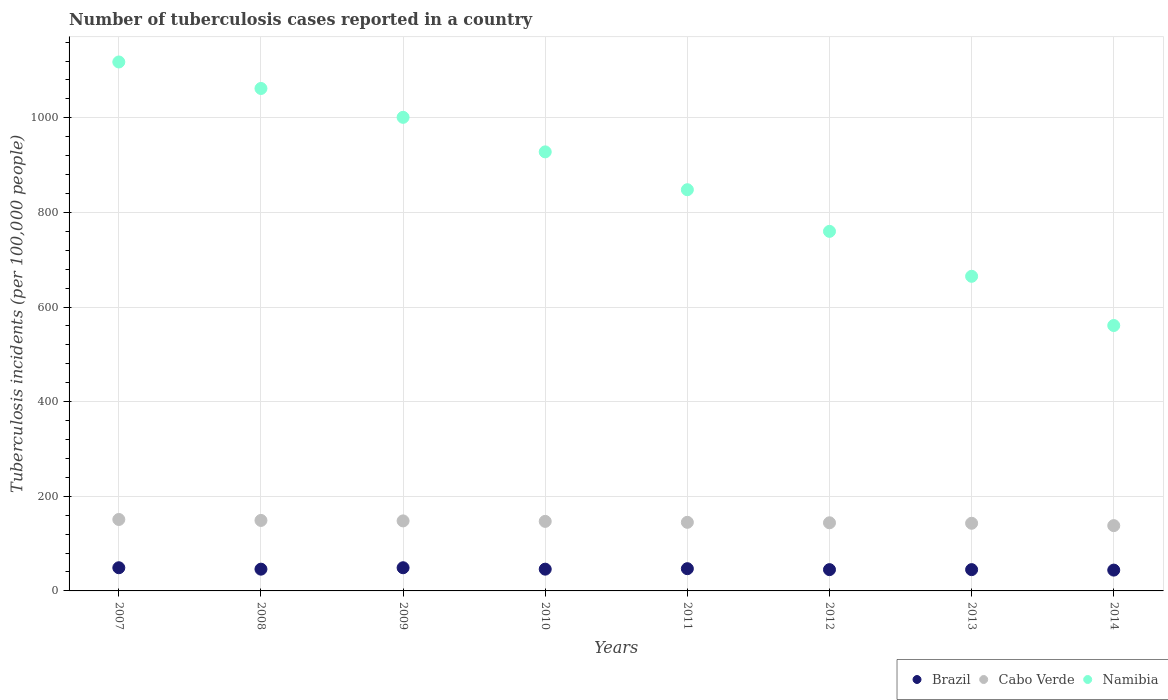Is the number of dotlines equal to the number of legend labels?
Offer a very short reply. Yes. What is the number of tuberculosis cases reported in in Namibia in 2010?
Ensure brevity in your answer.  928. Across all years, what is the maximum number of tuberculosis cases reported in in Cabo Verde?
Offer a very short reply. 151. Across all years, what is the minimum number of tuberculosis cases reported in in Cabo Verde?
Provide a short and direct response. 138. In which year was the number of tuberculosis cases reported in in Cabo Verde maximum?
Provide a short and direct response. 2007. What is the total number of tuberculosis cases reported in in Namibia in the graph?
Make the answer very short. 6943. What is the difference between the number of tuberculosis cases reported in in Cabo Verde in 2009 and that in 2012?
Provide a succinct answer. 4. What is the difference between the number of tuberculosis cases reported in in Namibia in 2014 and the number of tuberculosis cases reported in in Cabo Verde in 2007?
Provide a short and direct response. 410. What is the average number of tuberculosis cases reported in in Namibia per year?
Provide a short and direct response. 867.88. In the year 2008, what is the difference between the number of tuberculosis cases reported in in Cabo Verde and number of tuberculosis cases reported in in Brazil?
Your response must be concise. 103. In how many years, is the number of tuberculosis cases reported in in Namibia greater than 40?
Offer a terse response. 8. What is the ratio of the number of tuberculosis cases reported in in Cabo Verde in 2009 to that in 2014?
Provide a short and direct response. 1.07. Is the difference between the number of tuberculosis cases reported in in Cabo Verde in 2007 and 2012 greater than the difference between the number of tuberculosis cases reported in in Brazil in 2007 and 2012?
Your answer should be very brief. Yes. What is the difference between the highest and the lowest number of tuberculosis cases reported in in Namibia?
Keep it short and to the point. 557. Does the number of tuberculosis cases reported in in Namibia monotonically increase over the years?
Offer a terse response. No. Is the number of tuberculosis cases reported in in Namibia strictly greater than the number of tuberculosis cases reported in in Brazil over the years?
Provide a short and direct response. Yes. How many years are there in the graph?
Provide a short and direct response. 8. What is the difference between two consecutive major ticks on the Y-axis?
Your answer should be compact. 200. Are the values on the major ticks of Y-axis written in scientific E-notation?
Make the answer very short. No. Does the graph contain any zero values?
Keep it short and to the point. No. Does the graph contain grids?
Give a very brief answer. Yes. How are the legend labels stacked?
Make the answer very short. Horizontal. What is the title of the graph?
Your answer should be very brief. Number of tuberculosis cases reported in a country. Does "Low income" appear as one of the legend labels in the graph?
Ensure brevity in your answer.  No. What is the label or title of the X-axis?
Offer a terse response. Years. What is the label or title of the Y-axis?
Make the answer very short. Tuberculosis incidents (per 100,0 people). What is the Tuberculosis incidents (per 100,000 people) of Cabo Verde in 2007?
Your answer should be very brief. 151. What is the Tuberculosis incidents (per 100,000 people) in Namibia in 2007?
Offer a terse response. 1118. What is the Tuberculosis incidents (per 100,000 people) in Cabo Verde in 2008?
Ensure brevity in your answer.  149. What is the Tuberculosis incidents (per 100,000 people) of Namibia in 2008?
Provide a succinct answer. 1062. What is the Tuberculosis incidents (per 100,000 people) of Brazil in 2009?
Make the answer very short. 49. What is the Tuberculosis incidents (per 100,000 people) in Cabo Verde in 2009?
Your response must be concise. 148. What is the Tuberculosis incidents (per 100,000 people) in Namibia in 2009?
Offer a terse response. 1001. What is the Tuberculosis incidents (per 100,000 people) in Cabo Verde in 2010?
Provide a succinct answer. 147. What is the Tuberculosis incidents (per 100,000 people) of Namibia in 2010?
Your answer should be very brief. 928. What is the Tuberculosis incidents (per 100,000 people) in Brazil in 2011?
Your answer should be compact. 47. What is the Tuberculosis incidents (per 100,000 people) in Cabo Verde in 2011?
Provide a short and direct response. 145. What is the Tuberculosis incidents (per 100,000 people) of Namibia in 2011?
Ensure brevity in your answer.  848. What is the Tuberculosis incidents (per 100,000 people) in Cabo Verde in 2012?
Offer a terse response. 144. What is the Tuberculosis incidents (per 100,000 people) in Namibia in 2012?
Your response must be concise. 760. What is the Tuberculosis incidents (per 100,000 people) in Brazil in 2013?
Your response must be concise. 45. What is the Tuberculosis incidents (per 100,000 people) in Cabo Verde in 2013?
Your answer should be very brief. 143. What is the Tuberculosis incidents (per 100,000 people) in Namibia in 2013?
Your answer should be compact. 665. What is the Tuberculosis incidents (per 100,000 people) of Brazil in 2014?
Offer a terse response. 44. What is the Tuberculosis incidents (per 100,000 people) in Cabo Verde in 2014?
Provide a succinct answer. 138. What is the Tuberculosis incidents (per 100,000 people) in Namibia in 2014?
Your response must be concise. 561. Across all years, what is the maximum Tuberculosis incidents (per 100,000 people) in Cabo Verde?
Provide a succinct answer. 151. Across all years, what is the maximum Tuberculosis incidents (per 100,000 people) of Namibia?
Provide a succinct answer. 1118. Across all years, what is the minimum Tuberculosis incidents (per 100,000 people) of Brazil?
Give a very brief answer. 44. Across all years, what is the minimum Tuberculosis incidents (per 100,000 people) in Cabo Verde?
Your answer should be very brief. 138. Across all years, what is the minimum Tuberculosis incidents (per 100,000 people) of Namibia?
Your answer should be compact. 561. What is the total Tuberculosis incidents (per 100,000 people) of Brazil in the graph?
Your answer should be compact. 371. What is the total Tuberculosis incidents (per 100,000 people) of Cabo Verde in the graph?
Ensure brevity in your answer.  1165. What is the total Tuberculosis incidents (per 100,000 people) in Namibia in the graph?
Give a very brief answer. 6943. What is the difference between the Tuberculosis incidents (per 100,000 people) in Brazil in 2007 and that in 2008?
Your answer should be compact. 3. What is the difference between the Tuberculosis incidents (per 100,000 people) of Cabo Verde in 2007 and that in 2009?
Your answer should be very brief. 3. What is the difference between the Tuberculosis incidents (per 100,000 people) of Namibia in 2007 and that in 2009?
Make the answer very short. 117. What is the difference between the Tuberculosis incidents (per 100,000 people) in Cabo Verde in 2007 and that in 2010?
Keep it short and to the point. 4. What is the difference between the Tuberculosis incidents (per 100,000 people) in Namibia in 2007 and that in 2010?
Offer a terse response. 190. What is the difference between the Tuberculosis incidents (per 100,000 people) in Namibia in 2007 and that in 2011?
Your response must be concise. 270. What is the difference between the Tuberculosis incidents (per 100,000 people) of Cabo Verde in 2007 and that in 2012?
Offer a terse response. 7. What is the difference between the Tuberculosis incidents (per 100,000 people) of Namibia in 2007 and that in 2012?
Offer a very short reply. 358. What is the difference between the Tuberculosis incidents (per 100,000 people) of Namibia in 2007 and that in 2013?
Your answer should be compact. 453. What is the difference between the Tuberculosis incidents (per 100,000 people) of Cabo Verde in 2007 and that in 2014?
Provide a succinct answer. 13. What is the difference between the Tuberculosis incidents (per 100,000 people) in Namibia in 2007 and that in 2014?
Offer a terse response. 557. What is the difference between the Tuberculosis incidents (per 100,000 people) of Cabo Verde in 2008 and that in 2009?
Your answer should be very brief. 1. What is the difference between the Tuberculosis incidents (per 100,000 people) in Namibia in 2008 and that in 2009?
Offer a very short reply. 61. What is the difference between the Tuberculosis incidents (per 100,000 people) of Cabo Verde in 2008 and that in 2010?
Offer a very short reply. 2. What is the difference between the Tuberculosis incidents (per 100,000 people) of Namibia in 2008 and that in 2010?
Your answer should be very brief. 134. What is the difference between the Tuberculosis incidents (per 100,000 people) in Brazil in 2008 and that in 2011?
Offer a terse response. -1. What is the difference between the Tuberculosis incidents (per 100,000 people) in Cabo Verde in 2008 and that in 2011?
Give a very brief answer. 4. What is the difference between the Tuberculosis incidents (per 100,000 people) in Namibia in 2008 and that in 2011?
Provide a short and direct response. 214. What is the difference between the Tuberculosis incidents (per 100,000 people) in Cabo Verde in 2008 and that in 2012?
Your response must be concise. 5. What is the difference between the Tuberculosis incidents (per 100,000 people) of Namibia in 2008 and that in 2012?
Your answer should be compact. 302. What is the difference between the Tuberculosis incidents (per 100,000 people) of Cabo Verde in 2008 and that in 2013?
Provide a short and direct response. 6. What is the difference between the Tuberculosis incidents (per 100,000 people) in Namibia in 2008 and that in 2013?
Your answer should be very brief. 397. What is the difference between the Tuberculosis incidents (per 100,000 people) in Brazil in 2008 and that in 2014?
Keep it short and to the point. 2. What is the difference between the Tuberculosis incidents (per 100,000 people) of Namibia in 2008 and that in 2014?
Your answer should be compact. 501. What is the difference between the Tuberculosis incidents (per 100,000 people) in Brazil in 2009 and that in 2011?
Keep it short and to the point. 2. What is the difference between the Tuberculosis incidents (per 100,000 people) of Namibia in 2009 and that in 2011?
Offer a very short reply. 153. What is the difference between the Tuberculosis incidents (per 100,000 people) in Brazil in 2009 and that in 2012?
Your answer should be very brief. 4. What is the difference between the Tuberculosis incidents (per 100,000 people) in Cabo Verde in 2009 and that in 2012?
Offer a terse response. 4. What is the difference between the Tuberculosis incidents (per 100,000 people) in Namibia in 2009 and that in 2012?
Keep it short and to the point. 241. What is the difference between the Tuberculosis incidents (per 100,000 people) of Brazil in 2009 and that in 2013?
Provide a short and direct response. 4. What is the difference between the Tuberculosis incidents (per 100,000 people) in Cabo Verde in 2009 and that in 2013?
Provide a short and direct response. 5. What is the difference between the Tuberculosis incidents (per 100,000 people) in Namibia in 2009 and that in 2013?
Make the answer very short. 336. What is the difference between the Tuberculosis incidents (per 100,000 people) in Brazil in 2009 and that in 2014?
Provide a short and direct response. 5. What is the difference between the Tuberculosis incidents (per 100,000 people) of Namibia in 2009 and that in 2014?
Ensure brevity in your answer.  440. What is the difference between the Tuberculosis incidents (per 100,000 people) of Brazil in 2010 and that in 2011?
Provide a succinct answer. -1. What is the difference between the Tuberculosis incidents (per 100,000 people) in Brazil in 2010 and that in 2012?
Keep it short and to the point. 1. What is the difference between the Tuberculosis incidents (per 100,000 people) in Cabo Verde in 2010 and that in 2012?
Your answer should be very brief. 3. What is the difference between the Tuberculosis incidents (per 100,000 people) of Namibia in 2010 and that in 2012?
Keep it short and to the point. 168. What is the difference between the Tuberculosis incidents (per 100,000 people) in Cabo Verde in 2010 and that in 2013?
Provide a short and direct response. 4. What is the difference between the Tuberculosis incidents (per 100,000 people) in Namibia in 2010 and that in 2013?
Provide a short and direct response. 263. What is the difference between the Tuberculosis incidents (per 100,000 people) of Brazil in 2010 and that in 2014?
Your answer should be compact. 2. What is the difference between the Tuberculosis incidents (per 100,000 people) of Cabo Verde in 2010 and that in 2014?
Provide a short and direct response. 9. What is the difference between the Tuberculosis incidents (per 100,000 people) of Namibia in 2010 and that in 2014?
Your answer should be very brief. 367. What is the difference between the Tuberculosis incidents (per 100,000 people) in Cabo Verde in 2011 and that in 2012?
Offer a very short reply. 1. What is the difference between the Tuberculosis incidents (per 100,000 people) of Namibia in 2011 and that in 2012?
Provide a succinct answer. 88. What is the difference between the Tuberculosis incidents (per 100,000 people) in Cabo Verde in 2011 and that in 2013?
Your answer should be compact. 2. What is the difference between the Tuberculosis incidents (per 100,000 people) of Namibia in 2011 and that in 2013?
Keep it short and to the point. 183. What is the difference between the Tuberculosis incidents (per 100,000 people) of Namibia in 2011 and that in 2014?
Make the answer very short. 287. What is the difference between the Tuberculosis incidents (per 100,000 people) in Brazil in 2012 and that in 2013?
Give a very brief answer. 0. What is the difference between the Tuberculosis incidents (per 100,000 people) in Cabo Verde in 2012 and that in 2013?
Give a very brief answer. 1. What is the difference between the Tuberculosis incidents (per 100,000 people) of Cabo Verde in 2012 and that in 2014?
Give a very brief answer. 6. What is the difference between the Tuberculosis incidents (per 100,000 people) of Namibia in 2012 and that in 2014?
Provide a succinct answer. 199. What is the difference between the Tuberculosis incidents (per 100,000 people) in Cabo Verde in 2013 and that in 2014?
Provide a short and direct response. 5. What is the difference between the Tuberculosis incidents (per 100,000 people) of Namibia in 2013 and that in 2014?
Offer a terse response. 104. What is the difference between the Tuberculosis incidents (per 100,000 people) of Brazil in 2007 and the Tuberculosis incidents (per 100,000 people) of Cabo Verde in 2008?
Your response must be concise. -100. What is the difference between the Tuberculosis incidents (per 100,000 people) in Brazil in 2007 and the Tuberculosis incidents (per 100,000 people) in Namibia in 2008?
Provide a short and direct response. -1013. What is the difference between the Tuberculosis incidents (per 100,000 people) in Cabo Verde in 2007 and the Tuberculosis incidents (per 100,000 people) in Namibia in 2008?
Offer a very short reply. -911. What is the difference between the Tuberculosis incidents (per 100,000 people) of Brazil in 2007 and the Tuberculosis incidents (per 100,000 people) of Cabo Verde in 2009?
Give a very brief answer. -99. What is the difference between the Tuberculosis incidents (per 100,000 people) of Brazil in 2007 and the Tuberculosis incidents (per 100,000 people) of Namibia in 2009?
Make the answer very short. -952. What is the difference between the Tuberculosis incidents (per 100,000 people) in Cabo Verde in 2007 and the Tuberculosis incidents (per 100,000 people) in Namibia in 2009?
Your response must be concise. -850. What is the difference between the Tuberculosis incidents (per 100,000 people) in Brazil in 2007 and the Tuberculosis incidents (per 100,000 people) in Cabo Verde in 2010?
Offer a very short reply. -98. What is the difference between the Tuberculosis incidents (per 100,000 people) of Brazil in 2007 and the Tuberculosis incidents (per 100,000 people) of Namibia in 2010?
Give a very brief answer. -879. What is the difference between the Tuberculosis incidents (per 100,000 people) in Cabo Verde in 2007 and the Tuberculosis incidents (per 100,000 people) in Namibia in 2010?
Your answer should be compact. -777. What is the difference between the Tuberculosis incidents (per 100,000 people) in Brazil in 2007 and the Tuberculosis incidents (per 100,000 people) in Cabo Verde in 2011?
Your answer should be compact. -96. What is the difference between the Tuberculosis incidents (per 100,000 people) of Brazil in 2007 and the Tuberculosis incidents (per 100,000 people) of Namibia in 2011?
Make the answer very short. -799. What is the difference between the Tuberculosis incidents (per 100,000 people) in Cabo Verde in 2007 and the Tuberculosis incidents (per 100,000 people) in Namibia in 2011?
Provide a short and direct response. -697. What is the difference between the Tuberculosis incidents (per 100,000 people) of Brazil in 2007 and the Tuberculosis incidents (per 100,000 people) of Cabo Verde in 2012?
Give a very brief answer. -95. What is the difference between the Tuberculosis incidents (per 100,000 people) in Brazil in 2007 and the Tuberculosis incidents (per 100,000 people) in Namibia in 2012?
Provide a short and direct response. -711. What is the difference between the Tuberculosis incidents (per 100,000 people) of Cabo Verde in 2007 and the Tuberculosis incidents (per 100,000 people) of Namibia in 2012?
Offer a very short reply. -609. What is the difference between the Tuberculosis incidents (per 100,000 people) in Brazil in 2007 and the Tuberculosis incidents (per 100,000 people) in Cabo Verde in 2013?
Offer a terse response. -94. What is the difference between the Tuberculosis incidents (per 100,000 people) in Brazil in 2007 and the Tuberculosis incidents (per 100,000 people) in Namibia in 2013?
Make the answer very short. -616. What is the difference between the Tuberculosis incidents (per 100,000 people) of Cabo Verde in 2007 and the Tuberculosis incidents (per 100,000 people) of Namibia in 2013?
Provide a succinct answer. -514. What is the difference between the Tuberculosis incidents (per 100,000 people) of Brazil in 2007 and the Tuberculosis incidents (per 100,000 people) of Cabo Verde in 2014?
Provide a short and direct response. -89. What is the difference between the Tuberculosis incidents (per 100,000 people) of Brazil in 2007 and the Tuberculosis incidents (per 100,000 people) of Namibia in 2014?
Give a very brief answer. -512. What is the difference between the Tuberculosis incidents (per 100,000 people) in Cabo Verde in 2007 and the Tuberculosis incidents (per 100,000 people) in Namibia in 2014?
Offer a very short reply. -410. What is the difference between the Tuberculosis incidents (per 100,000 people) in Brazil in 2008 and the Tuberculosis incidents (per 100,000 people) in Cabo Verde in 2009?
Your answer should be compact. -102. What is the difference between the Tuberculosis incidents (per 100,000 people) in Brazil in 2008 and the Tuberculosis incidents (per 100,000 people) in Namibia in 2009?
Your answer should be very brief. -955. What is the difference between the Tuberculosis incidents (per 100,000 people) of Cabo Verde in 2008 and the Tuberculosis incidents (per 100,000 people) of Namibia in 2009?
Your answer should be compact. -852. What is the difference between the Tuberculosis incidents (per 100,000 people) of Brazil in 2008 and the Tuberculosis incidents (per 100,000 people) of Cabo Verde in 2010?
Your response must be concise. -101. What is the difference between the Tuberculosis incidents (per 100,000 people) of Brazil in 2008 and the Tuberculosis incidents (per 100,000 people) of Namibia in 2010?
Provide a succinct answer. -882. What is the difference between the Tuberculosis incidents (per 100,000 people) of Cabo Verde in 2008 and the Tuberculosis incidents (per 100,000 people) of Namibia in 2010?
Offer a very short reply. -779. What is the difference between the Tuberculosis incidents (per 100,000 people) of Brazil in 2008 and the Tuberculosis incidents (per 100,000 people) of Cabo Verde in 2011?
Your answer should be very brief. -99. What is the difference between the Tuberculosis incidents (per 100,000 people) in Brazil in 2008 and the Tuberculosis incidents (per 100,000 people) in Namibia in 2011?
Your answer should be very brief. -802. What is the difference between the Tuberculosis incidents (per 100,000 people) of Cabo Verde in 2008 and the Tuberculosis incidents (per 100,000 people) of Namibia in 2011?
Your answer should be very brief. -699. What is the difference between the Tuberculosis incidents (per 100,000 people) in Brazil in 2008 and the Tuberculosis incidents (per 100,000 people) in Cabo Verde in 2012?
Your answer should be compact. -98. What is the difference between the Tuberculosis incidents (per 100,000 people) of Brazil in 2008 and the Tuberculosis incidents (per 100,000 people) of Namibia in 2012?
Your response must be concise. -714. What is the difference between the Tuberculosis incidents (per 100,000 people) in Cabo Verde in 2008 and the Tuberculosis incidents (per 100,000 people) in Namibia in 2012?
Your answer should be very brief. -611. What is the difference between the Tuberculosis incidents (per 100,000 people) in Brazil in 2008 and the Tuberculosis incidents (per 100,000 people) in Cabo Verde in 2013?
Provide a succinct answer. -97. What is the difference between the Tuberculosis incidents (per 100,000 people) in Brazil in 2008 and the Tuberculosis incidents (per 100,000 people) in Namibia in 2013?
Your response must be concise. -619. What is the difference between the Tuberculosis incidents (per 100,000 people) of Cabo Verde in 2008 and the Tuberculosis incidents (per 100,000 people) of Namibia in 2013?
Your answer should be compact. -516. What is the difference between the Tuberculosis incidents (per 100,000 people) in Brazil in 2008 and the Tuberculosis incidents (per 100,000 people) in Cabo Verde in 2014?
Ensure brevity in your answer.  -92. What is the difference between the Tuberculosis incidents (per 100,000 people) in Brazil in 2008 and the Tuberculosis incidents (per 100,000 people) in Namibia in 2014?
Your answer should be very brief. -515. What is the difference between the Tuberculosis incidents (per 100,000 people) in Cabo Verde in 2008 and the Tuberculosis incidents (per 100,000 people) in Namibia in 2014?
Ensure brevity in your answer.  -412. What is the difference between the Tuberculosis incidents (per 100,000 people) in Brazil in 2009 and the Tuberculosis incidents (per 100,000 people) in Cabo Verde in 2010?
Keep it short and to the point. -98. What is the difference between the Tuberculosis incidents (per 100,000 people) of Brazil in 2009 and the Tuberculosis incidents (per 100,000 people) of Namibia in 2010?
Your answer should be compact. -879. What is the difference between the Tuberculosis incidents (per 100,000 people) of Cabo Verde in 2009 and the Tuberculosis incidents (per 100,000 people) of Namibia in 2010?
Provide a succinct answer. -780. What is the difference between the Tuberculosis incidents (per 100,000 people) in Brazil in 2009 and the Tuberculosis incidents (per 100,000 people) in Cabo Verde in 2011?
Offer a very short reply. -96. What is the difference between the Tuberculosis incidents (per 100,000 people) of Brazil in 2009 and the Tuberculosis incidents (per 100,000 people) of Namibia in 2011?
Give a very brief answer. -799. What is the difference between the Tuberculosis incidents (per 100,000 people) of Cabo Verde in 2009 and the Tuberculosis incidents (per 100,000 people) of Namibia in 2011?
Your response must be concise. -700. What is the difference between the Tuberculosis incidents (per 100,000 people) of Brazil in 2009 and the Tuberculosis incidents (per 100,000 people) of Cabo Verde in 2012?
Make the answer very short. -95. What is the difference between the Tuberculosis incidents (per 100,000 people) in Brazil in 2009 and the Tuberculosis incidents (per 100,000 people) in Namibia in 2012?
Provide a succinct answer. -711. What is the difference between the Tuberculosis incidents (per 100,000 people) in Cabo Verde in 2009 and the Tuberculosis incidents (per 100,000 people) in Namibia in 2012?
Your answer should be compact. -612. What is the difference between the Tuberculosis incidents (per 100,000 people) in Brazil in 2009 and the Tuberculosis incidents (per 100,000 people) in Cabo Verde in 2013?
Your answer should be very brief. -94. What is the difference between the Tuberculosis incidents (per 100,000 people) in Brazil in 2009 and the Tuberculosis incidents (per 100,000 people) in Namibia in 2013?
Ensure brevity in your answer.  -616. What is the difference between the Tuberculosis incidents (per 100,000 people) in Cabo Verde in 2009 and the Tuberculosis incidents (per 100,000 people) in Namibia in 2013?
Your answer should be compact. -517. What is the difference between the Tuberculosis incidents (per 100,000 people) in Brazil in 2009 and the Tuberculosis incidents (per 100,000 people) in Cabo Verde in 2014?
Make the answer very short. -89. What is the difference between the Tuberculosis incidents (per 100,000 people) in Brazil in 2009 and the Tuberculosis incidents (per 100,000 people) in Namibia in 2014?
Give a very brief answer. -512. What is the difference between the Tuberculosis incidents (per 100,000 people) of Cabo Verde in 2009 and the Tuberculosis incidents (per 100,000 people) of Namibia in 2014?
Provide a short and direct response. -413. What is the difference between the Tuberculosis incidents (per 100,000 people) in Brazil in 2010 and the Tuberculosis incidents (per 100,000 people) in Cabo Verde in 2011?
Offer a terse response. -99. What is the difference between the Tuberculosis incidents (per 100,000 people) of Brazil in 2010 and the Tuberculosis incidents (per 100,000 people) of Namibia in 2011?
Offer a very short reply. -802. What is the difference between the Tuberculosis incidents (per 100,000 people) in Cabo Verde in 2010 and the Tuberculosis incidents (per 100,000 people) in Namibia in 2011?
Give a very brief answer. -701. What is the difference between the Tuberculosis incidents (per 100,000 people) of Brazil in 2010 and the Tuberculosis incidents (per 100,000 people) of Cabo Verde in 2012?
Keep it short and to the point. -98. What is the difference between the Tuberculosis incidents (per 100,000 people) in Brazil in 2010 and the Tuberculosis incidents (per 100,000 people) in Namibia in 2012?
Give a very brief answer. -714. What is the difference between the Tuberculosis incidents (per 100,000 people) in Cabo Verde in 2010 and the Tuberculosis incidents (per 100,000 people) in Namibia in 2012?
Offer a terse response. -613. What is the difference between the Tuberculosis incidents (per 100,000 people) in Brazil in 2010 and the Tuberculosis incidents (per 100,000 people) in Cabo Verde in 2013?
Ensure brevity in your answer.  -97. What is the difference between the Tuberculosis incidents (per 100,000 people) in Brazil in 2010 and the Tuberculosis incidents (per 100,000 people) in Namibia in 2013?
Give a very brief answer. -619. What is the difference between the Tuberculosis incidents (per 100,000 people) in Cabo Verde in 2010 and the Tuberculosis incidents (per 100,000 people) in Namibia in 2013?
Make the answer very short. -518. What is the difference between the Tuberculosis incidents (per 100,000 people) of Brazil in 2010 and the Tuberculosis incidents (per 100,000 people) of Cabo Verde in 2014?
Ensure brevity in your answer.  -92. What is the difference between the Tuberculosis incidents (per 100,000 people) of Brazil in 2010 and the Tuberculosis incidents (per 100,000 people) of Namibia in 2014?
Your answer should be compact. -515. What is the difference between the Tuberculosis incidents (per 100,000 people) in Cabo Verde in 2010 and the Tuberculosis incidents (per 100,000 people) in Namibia in 2014?
Give a very brief answer. -414. What is the difference between the Tuberculosis incidents (per 100,000 people) of Brazil in 2011 and the Tuberculosis incidents (per 100,000 people) of Cabo Verde in 2012?
Keep it short and to the point. -97. What is the difference between the Tuberculosis incidents (per 100,000 people) in Brazil in 2011 and the Tuberculosis incidents (per 100,000 people) in Namibia in 2012?
Ensure brevity in your answer.  -713. What is the difference between the Tuberculosis incidents (per 100,000 people) of Cabo Verde in 2011 and the Tuberculosis incidents (per 100,000 people) of Namibia in 2012?
Offer a very short reply. -615. What is the difference between the Tuberculosis incidents (per 100,000 people) in Brazil in 2011 and the Tuberculosis incidents (per 100,000 people) in Cabo Verde in 2013?
Offer a terse response. -96. What is the difference between the Tuberculosis incidents (per 100,000 people) of Brazil in 2011 and the Tuberculosis incidents (per 100,000 people) of Namibia in 2013?
Offer a very short reply. -618. What is the difference between the Tuberculosis incidents (per 100,000 people) in Cabo Verde in 2011 and the Tuberculosis incidents (per 100,000 people) in Namibia in 2013?
Give a very brief answer. -520. What is the difference between the Tuberculosis incidents (per 100,000 people) of Brazil in 2011 and the Tuberculosis incidents (per 100,000 people) of Cabo Verde in 2014?
Make the answer very short. -91. What is the difference between the Tuberculosis incidents (per 100,000 people) in Brazil in 2011 and the Tuberculosis incidents (per 100,000 people) in Namibia in 2014?
Your response must be concise. -514. What is the difference between the Tuberculosis incidents (per 100,000 people) of Cabo Verde in 2011 and the Tuberculosis incidents (per 100,000 people) of Namibia in 2014?
Your answer should be very brief. -416. What is the difference between the Tuberculosis incidents (per 100,000 people) of Brazil in 2012 and the Tuberculosis incidents (per 100,000 people) of Cabo Verde in 2013?
Give a very brief answer. -98. What is the difference between the Tuberculosis incidents (per 100,000 people) of Brazil in 2012 and the Tuberculosis incidents (per 100,000 people) of Namibia in 2013?
Keep it short and to the point. -620. What is the difference between the Tuberculosis incidents (per 100,000 people) in Cabo Verde in 2012 and the Tuberculosis incidents (per 100,000 people) in Namibia in 2013?
Make the answer very short. -521. What is the difference between the Tuberculosis incidents (per 100,000 people) in Brazil in 2012 and the Tuberculosis incidents (per 100,000 people) in Cabo Verde in 2014?
Ensure brevity in your answer.  -93. What is the difference between the Tuberculosis incidents (per 100,000 people) of Brazil in 2012 and the Tuberculosis incidents (per 100,000 people) of Namibia in 2014?
Your answer should be compact. -516. What is the difference between the Tuberculosis incidents (per 100,000 people) in Cabo Verde in 2012 and the Tuberculosis incidents (per 100,000 people) in Namibia in 2014?
Your answer should be compact. -417. What is the difference between the Tuberculosis incidents (per 100,000 people) in Brazil in 2013 and the Tuberculosis incidents (per 100,000 people) in Cabo Verde in 2014?
Ensure brevity in your answer.  -93. What is the difference between the Tuberculosis incidents (per 100,000 people) in Brazil in 2013 and the Tuberculosis incidents (per 100,000 people) in Namibia in 2014?
Offer a terse response. -516. What is the difference between the Tuberculosis incidents (per 100,000 people) in Cabo Verde in 2013 and the Tuberculosis incidents (per 100,000 people) in Namibia in 2014?
Ensure brevity in your answer.  -418. What is the average Tuberculosis incidents (per 100,000 people) in Brazil per year?
Offer a very short reply. 46.38. What is the average Tuberculosis incidents (per 100,000 people) in Cabo Verde per year?
Your answer should be very brief. 145.62. What is the average Tuberculosis incidents (per 100,000 people) of Namibia per year?
Your answer should be very brief. 867.88. In the year 2007, what is the difference between the Tuberculosis incidents (per 100,000 people) of Brazil and Tuberculosis incidents (per 100,000 people) of Cabo Verde?
Give a very brief answer. -102. In the year 2007, what is the difference between the Tuberculosis incidents (per 100,000 people) of Brazil and Tuberculosis incidents (per 100,000 people) of Namibia?
Your answer should be very brief. -1069. In the year 2007, what is the difference between the Tuberculosis incidents (per 100,000 people) in Cabo Verde and Tuberculosis incidents (per 100,000 people) in Namibia?
Keep it short and to the point. -967. In the year 2008, what is the difference between the Tuberculosis incidents (per 100,000 people) in Brazil and Tuberculosis incidents (per 100,000 people) in Cabo Verde?
Provide a short and direct response. -103. In the year 2008, what is the difference between the Tuberculosis incidents (per 100,000 people) of Brazil and Tuberculosis incidents (per 100,000 people) of Namibia?
Provide a short and direct response. -1016. In the year 2008, what is the difference between the Tuberculosis incidents (per 100,000 people) in Cabo Verde and Tuberculosis incidents (per 100,000 people) in Namibia?
Your response must be concise. -913. In the year 2009, what is the difference between the Tuberculosis incidents (per 100,000 people) of Brazil and Tuberculosis incidents (per 100,000 people) of Cabo Verde?
Provide a short and direct response. -99. In the year 2009, what is the difference between the Tuberculosis incidents (per 100,000 people) in Brazil and Tuberculosis incidents (per 100,000 people) in Namibia?
Provide a short and direct response. -952. In the year 2009, what is the difference between the Tuberculosis incidents (per 100,000 people) of Cabo Verde and Tuberculosis incidents (per 100,000 people) of Namibia?
Give a very brief answer. -853. In the year 2010, what is the difference between the Tuberculosis incidents (per 100,000 people) of Brazil and Tuberculosis incidents (per 100,000 people) of Cabo Verde?
Ensure brevity in your answer.  -101. In the year 2010, what is the difference between the Tuberculosis incidents (per 100,000 people) of Brazil and Tuberculosis incidents (per 100,000 people) of Namibia?
Provide a succinct answer. -882. In the year 2010, what is the difference between the Tuberculosis incidents (per 100,000 people) of Cabo Verde and Tuberculosis incidents (per 100,000 people) of Namibia?
Keep it short and to the point. -781. In the year 2011, what is the difference between the Tuberculosis incidents (per 100,000 people) in Brazil and Tuberculosis incidents (per 100,000 people) in Cabo Verde?
Provide a short and direct response. -98. In the year 2011, what is the difference between the Tuberculosis incidents (per 100,000 people) in Brazil and Tuberculosis incidents (per 100,000 people) in Namibia?
Give a very brief answer. -801. In the year 2011, what is the difference between the Tuberculosis incidents (per 100,000 people) in Cabo Verde and Tuberculosis incidents (per 100,000 people) in Namibia?
Offer a terse response. -703. In the year 2012, what is the difference between the Tuberculosis incidents (per 100,000 people) of Brazil and Tuberculosis incidents (per 100,000 people) of Cabo Verde?
Make the answer very short. -99. In the year 2012, what is the difference between the Tuberculosis incidents (per 100,000 people) in Brazil and Tuberculosis incidents (per 100,000 people) in Namibia?
Offer a terse response. -715. In the year 2012, what is the difference between the Tuberculosis incidents (per 100,000 people) in Cabo Verde and Tuberculosis incidents (per 100,000 people) in Namibia?
Your response must be concise. -616. In the year 2013, what is the difference between the Tuberculosis incidents (per 100,000 people) of Brazil and Tuberculosis incidents (per 100,000 people) of Cabo Verde?
Your response must be concise. -98. In the year 2013, what is the difference between the Tuberculosis incidents (per 100,000 people) of Brazil and Tuberculosis incidents (per 100,000 people) of Namibia?
Keep it short and to the point. -620. In the year 2013, what is the difference between the Tuberculosis incidents (per 100,000 people) in Cabo Verde and Tuberculosis incidents (per 100,000 people) in Namibia?
Make the answer very short. -522. In the year 2014, what is the difference between the Tuberculosis incidents (per 100,000 people) in Brazil and Tuberculosis incidents (per 100,000 people) in Cabo Verde?
Make the answer very short. -94. In the year 2014, what is the difference between the Tuberculosis incidents (per 100,000 people) of Brazil and Tuberculosis incidents (per 100,000 people) of Namibia?
Provide a short and direct response. -517. In the year 2014, what is the difference between the Tuberculosis incidents (per 100,000 people) in Cabo Verde and Tuberculosis incidents (per 100,000 people) in Namibia?
Your response must be concise. -423. What is the ratio of the Tuberculosis incidents (per 100,000 people) of Brazil in 2007 to that in 2008?
Ensure brevity in your answer.  1.07. What is the ratio of the Tuberculosis incidents (per 100,000 people) of Cabo Verde in 2007 to that in 2008?
Give a very brief answer. 1.01. What is the ratio of the Tuberculosis incidents (per 100,000 people) of Namibia in 2007 to that in 2008?
Your response must be concise. 1.05. What is the ratio of the Tuberculosis incidents (per 100,000 people) in Cabo Verde in 2007 to that in 2009?
Give a very brief answer. 1.02. What is the ratio of the Tuberculosis incidents (per 100,000 people) in Namibia in 2007 to that in 2009?
Offer a terse response. 1.12. What is the ratio of the Tuberculosis incidents (per 100,000 people) of Brazil in 2007 to that in 2010?
Your response must be concise. 1.07. What is the ratio of the Tuberculosis incidents (per 100,000 people) in Cabo Verde in 2007 to that in 2010?
Your answer should be very brief. 1.03. What is the ratio of the Tuberculosis incidents (per 100,000 people) of Namibia in 2007 to that in 2010?
Keep it short and to the point. 1.2. What is the ratio of the Tuberculosis incidents (per 100,000 people) of Brazil in 2007 to that in 2011?
Ensure brevity in your answer.  1.04. What is the ratio of the Tuberculosis incidents (per 100,000 people) in Cabo Verde in 2007 to that in 2011?
Ensure brevity in your answer.  1.04. What is the ratio of the Tuberculosis incidents (per 100,000 people) of Namibia in 2007 to that in 2011?
Provide a succinct answer. 1.32. What is the ratio of the Tuberculosis incidents (per 100,000 people) of Brazil in 2007 to that in 2012?
Your answer should be compact. 1.09. What is the ratio of the Tuberculosis incidents (per 100,000 people) in Cabo Verde in 2007 to that in 2012?
Offer a terse response. 1.05. What is the ratio of the Tuberculosis incidents (per 100,000 people) of Namibia in 2007 to that in 2012?
Offer a very short reply. 1.47. What is the ratio of the Tuberculosis incidents (per 100,000 people) in Brazil in 2007 to that in 2013?
Your response must be concise. 1.09. What is the ratio of the Tuberculosis incidents (per 100,000 people) of Cabo Verde in 2007 to that in 2013?
Ensure brevity in your answer.  1.06. What is the ratio of the Tuberculosis incidents (per 100,000 people) in Namibia in 2007 to that in 2013?
Offer a terse response. 1.68. What is the ratio of the Tuberculosis incidents (per 100,000 people) in Brazil in 2007 to that in 2014?
Give a very brief answer. 1.11. What is the ratio of the Tuberculosis incidents (per 100,000 people) of Cabo Verde in 2007 to that in 2014?
Offer a very short reply. 1.09. What is the ratio of the Tuberculosis incidents (per 100,000 people) of Namibia in 2007 to that in 2014?
Your answer should be very brief. 1.99. What is the ratio of the Tuberculosis incidents (per 100,000 people) in Brazil in 2008 to that in 2009?
Offer a very short reply. 0.94. What is the ratio of the Tuberculosis incidents (per 100,000 people) in Cabo Verde in 2008 to that in 2009?
Keep it short and to the point. 1.01. What is the ratio of the Tuberculosis incidents (per 100,000 people) of Namibia in 2008 to that in 2009?
Provide a short and direct response. 1.06. What is the ratio of the Tuberculosis incidents (per 100,000 people) of Cabo Verde in 2008 to that in 2010?
Offer a very short reply. 1.01. What is the ratio of the Tuberculosis incidents (per 100,000 people) of Namibia in 2008 to that in 2010?
Provide a short and direct response. 1.14. What is the ratio of the Tuberculosis incidents (per 100,000 people) in Brazil in 2008 to that in 2011?
Provide a short and direct response. 0.98. What is the ratio of the Tuberculosis incidents (per 100,000 people) in Cabo Verde in 2008 to that in 2011?
Your answer should be very brief. 1.03. What is the ratio of the Tuberculosis incidents (per 100,000 people) in Namibia in 2008 to that in 2011?
Provide a short and direct response. 1.25. What is the ratio of the Tuberculosis incidents (per 100,000 people) of Brazil in 2008 to that in 2012?
Your answer should be very brief. 1.02. What is the ratio of the Tuberculosis incidents (per 100,000 people) in Cabo Verde in 2008 to that in 2012?
Offer a very short reply. 1.03. What is the ratio of the Tuberculosis incidents (per 100,000 people) in Namibia in 2008 to that in 2012?
Offer a terse response. 1.4. What is the ratio of the Tuberculosis incidents (per 100,000 people) of Brazil in 2008 to that in 2013?
Make the answer very short. 1.02. What is the ratio of the Tuberculosis incidents (per 100,000 people) of Cabo Verde in 2008 to that in 2013?
Your answer should be very brief. 1.04. What is the ratio of the Tuberculosis incidents (per 100,000 people) of Namibia in 2008 to that in 2013?
Your response must be concise. 1.6. What is the ratio of the Tuberculosis incidents (per 100,000 people) of Brazil in 2008 to that in 2014?
Your response must be concise. 1.05. What is the ratio of the Tuberculosis incidents (per 100,000 people) of Cabo Verde in 2008 to that in 2014?
Keep it short and to the point. 1.08. What is the ratio of the Tuberculosis incidents (per 100,000 people) in Namibia in 2008 to that in 2014?
Make the answer very short. 1.89. What is the ratio of the Tuberculosis incidents (per 100,000 people) of Brazil in 2009 to that in 2010?
Offer a very short reply. 1.07. What is the ratio of the Tuberculosis incidents (per 100,000 people) in Cabo Verde in 2009 to that in 2010?
Give a very brief answer. 1.01. What is the ratio of the Tuberculosis incidents (per 100,000 people) in Namibia in 2009 to that in 2010?
Your response must be concise. 1.08. What is the ratio of the Tuberculosis incidents (per 100,000 people) of Brazil in 2009 to that in 2011?
Offer a very short reply. 1.04. What is the ratio of the Tuberculosis incidents (per 100,000 people) in Cabo Verde in 2009 to that in 2011?
Give a very brief answer. 1.02. What is the ratio of the Tuberculosis incidents (per 100,000 people) of Namibia in 2009 to that in 2011?
Offer a terse response. 1.18. What is the ratio of the Tuberculosis incidents (per 100,000 people) of Brazil in 2009 to that in 2012?
Make the answer very short. 1.09. What is the ratio of the Tuberculosis incidents (per 100,000 people) of Cabo Verde in 2009 to that in 2012?
Your response must be concise. 1.03. What is the ratio of the Tuberculosis incidents (per 100,000 people) of Namibia in 2009 to that in 2012?
Keep it short and to the point. 1.32. What is the ratio of the Tuberculosis incidents (per 100,000 people) of Brazil in 2009 to that in 2013?
Make the answer very short. 1.09. What is the ratio of the Tuberculosis incidents (per 100,000 people) of Cabo Verde in 2009 to that in 2013?
Provide a short and direct response. 1.03. What is the ratio of the Tuberculosis incidents (per 100,000 people) of Namibia in 2009 to that in 2013?
Your answer should be compact. 1.51. What is the ratio of the Tuberculosis incidents (per 100,000 people) in Brazil in 2009 to that in 2014?
Ensure brevity in your answer.  1.11. What is the ratio of the Tuberculosis incidents (per 100,000 people) of Cabo Verde in 2009 to that in 2014?
Offer a very short reply. 1.07. What is the ratio of the Tuberculosis incidents (per 100,000 people) of Namibia in 2009 to that in 2014?
Your answer should be compact. 1.78. What is the ratio of the Tuberculosis incidents (per 100,000 people) of Brazil in 2010 to that in 2011?
Keep it short and to the point. 0.98. What is the ratio of the Tuberculosis incidents (per 100,000 people) of Cabo Verde in 2010 to that in 2011?
Ensure brevity in your answer.  1.01. What is the ratio of the Tuberculosis incidents (per 100,000 people) in Namibia in 2010 to that in 2011?
Make the answer very short. 1.09. What is the ratio of the Tuberculosis incidents (per 100,000 people) of Brazil in 2010 to that in 2012?
Provide a succinct answer. 1.02. What is the ratio of the Tuberculosis incidents (per 100,000 people) of Cabo Verde in 2010 to that in 2012?
Ensure brevity in your answer.  1.02. What is the ratio of the Tuberculosis incidents (per 100,000 people) in Namibia in 2010 to that in 2012?
Provide a short and direct response. 1.22. What is the ratio of the Tuberculosis incidents (per 100,000 people) of Brazil in 2010 to that in 2013?
Offer a terse response. 1.02. What is the ratio of the Tuberculosis incidents (per 100,000 people) in Cabo Verde in 2010 to that in 2013?
Your response must be concise. 1.03. What is the ratio of the Tuberculosis incidents (per 100,000 people) of Namibia in 2010 to that in 2013?
Your response must be concise. 1.4. What is the ratio of the Tuberculosis incidents (per 100,000 people) of Brazil in 2010 to that in 2014?
Offer a very short reply. 1.05. What is the ratio of the Tuberculosis incidents (per 100,000 people) in Cabo Verde in 2010 to that in 2014?
Offer a terse response. 1.07. What is the ratio of the Tuberculosis incidents (per 100,000 people) of Namibia in 2010 to that in 2014?
Ensure brevity in your answer.  1.65. What is the ratio of the Tuberculosis incidents (per 100,000 people) of Brazil in 2011 to that in 2012?
Provide a short and direct response. 1.04. What is the ratio of the Tuberculosis incidents (per 100,000 people) in Cabo Verde in 2011 to that in 2012?
Give a very brief answer. 1.01. What is the ratio of the Tuberculosis incidents (per 100,000 people) in Namibia in 2011 to that in 2012?
Keep it short and to the point. 1.12. What is the ratio of the Tuberculosis incidents (per 100,000 people) in Brazil in 2011 to that in 2013?
Provide a short and direct response. 1.04. What is the ratio of the Tuberculosis incidents (per 100,000 people) in Cabo Verde in 2011 to that in 2013?
Give a very brief answer. 1.01. What is the ratio of the Tuberculosis incidents (per 100,000 people) of Namibia in 2011 to that in 2013?
Make the answer very short. 1.28. What is the ratio of the Tuberculosis incidents (per 100,000 people) of Brazil in 2011 to that in 2014?
Your answer should be very brief. 1.07. What is the ratio of the Tuberculosis incidents (per 100,000 people) in Cabo Verde in 2011 to that in 2014?
Offer a terse response. 1.05. What is the ratio of the Tuberculosis incidents (per 100,000 people) of Namibia in 2011 to that in 2014?
Make the answer very short. 1.51. What is the ratio of the Tuberculosis incidents (per 100,000 people) in Brazil in 2012 to that in 2013?
Ensure brevity in your answer.  1. What is the ratio of the Tuberculosis incidents (per 100,000 people) in Namibia in 2012 to that in 2013?
Offer a very short reply. 1.14. What is the ratio of the Tuberculosis incidents (per 100,000 people) of Brazil in 2012 to that in 2014?
Provide a short and direct response. 1.02. What is the ratio of the Tuberculosis incidents (per 100,000 people) of Cabo Verde in 2012 to that in 2014?
Your answer should be compact. 1.04. What is the ratio of the Tuberculosis incidents (per 100,000 people) in Namibia in 2012 to that in 2014?
Your answer should be very brief. 1.35. What is the ratio of the Tuberculosis incidents (per 100,000 people) of Brazil in 2013 to that in 2014?
Give a very brief answer. 1.02. What is the ratio of the Tuberculosis incidents (per 100,000 people) of Cabo Verde in 2013 to that in 2014?
Offer a very short reply. 1.04. What is the ratio of the Tuberculosis incidents (per 100,000 people) in Namibia in 2013 to that in 2014?
Give a very brief answer. 1.19. What is the difference between the highest and the second highest Tuberculosis incidents (per 100,000 people) in Namibia?
Offer a very short reply. 56. What is the difference between the highest and the lowest Tuberculosis incidents (per 100,000 people) in Cabo Verde?
Your answer should be very brief. 13. What is the difference between the highest and the lowest Tuberculosis incidents (per 100,000 people) of Namibia?
Your answer should be very brief. 557. 